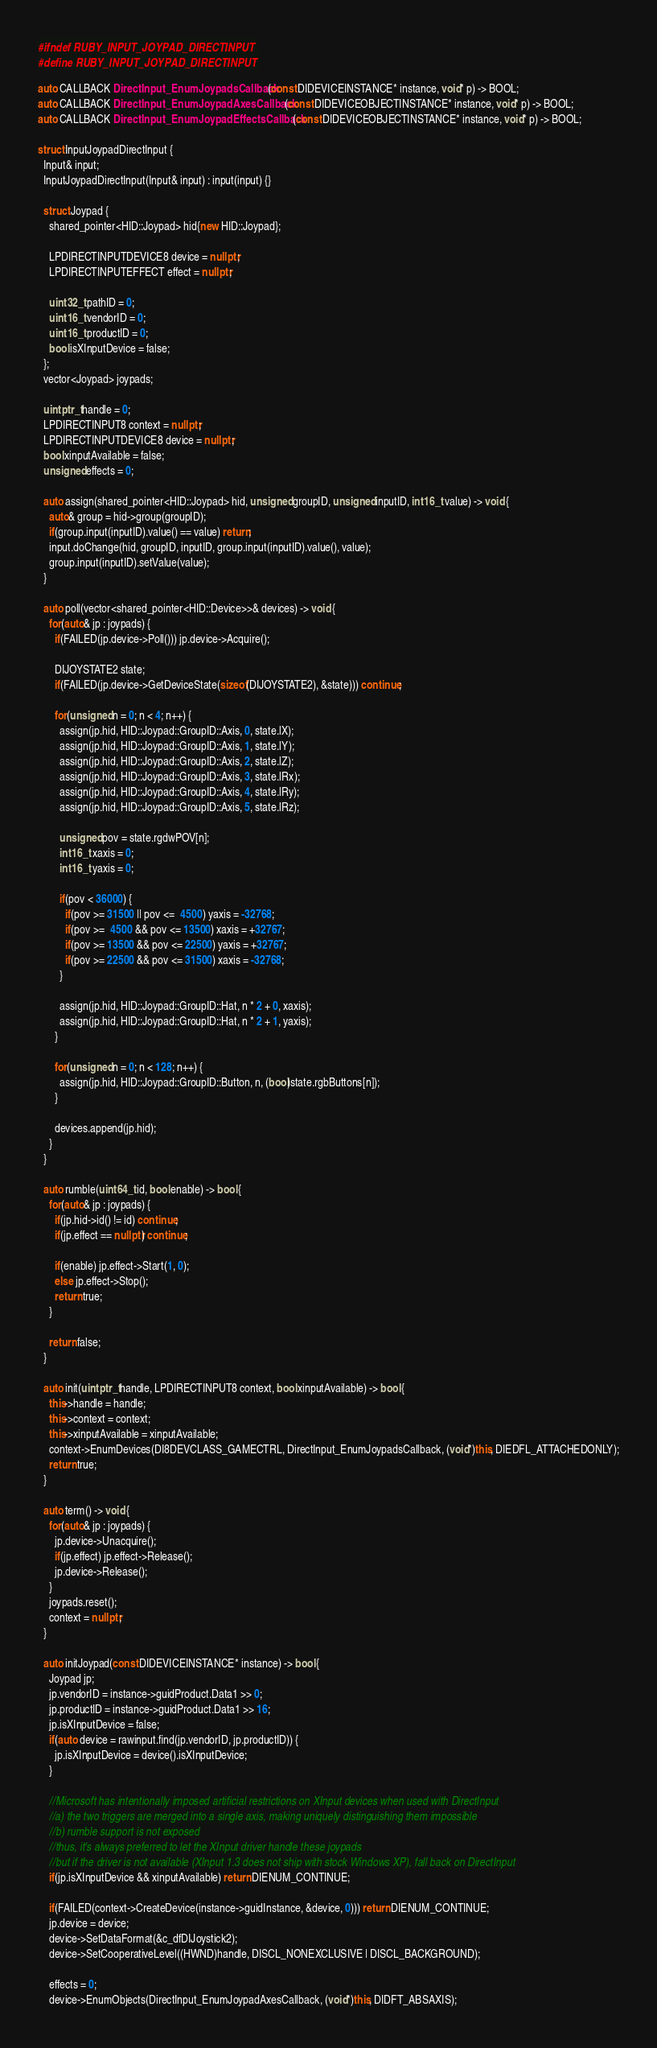<code> <loc_0><loc_0><loc_500><loc_500><_C++_>#ifndef RUBY_INPUT_JOYPAD_DIRECTINPUT
#define RUBY_INPUT_JOYPAD_DIRECTINPUT

auto CALLBACK DirectInput_EnumJoypadsCallback(const DIDEVICEINSTANCE* instance, void* p) -> BOOL;
auto CALLBACK DirectInput_EnumJoypadAxesCallback(const DIDEVICEOBJECTINSTANCE* instance, void* p) -> BOOL;
auto CALLBACK DirectInput_EnumJoypadEffectsCallback(const DIDEVICEOBJECTINSTANCE* instance, void* p) -> BOOL;

struct InputJoypadDirectInput {
  Input& input;
  InputJoypadDirectInput(Input& input) : input(input) {}

  struct Joypad {
    shared_pointer<HID::Joypad> hid{new HID::Joypad};

    LPDIRECTINPUTDEVICE8 device = nullptr;
    LPDIRECTINPUTEFFECT effect = nullptr;

    uint32_t pathID = 0;
    uint16_t vendorID = 0;
    uint16_t productID = 0;
    bool isXInputDevice = false;
  };
  vector<Joypad> joypads;

  uintptr_t handle = 0;
  LPDIRECTINPUT8 context = nullptr;
  LPDIRECTINPUTDEVICE8 device = nullptr;
  bool xinputAvailable = false;
  unsigned effects = 0;

  auto assign(shared_pointer<HID::Joypad> hid, unsigned groupID, unsigned inputID, int16_t value) -> void {
    auto& group = hid->group(groupID);
    if(group.input(inputID).value() == value) return;
    input.doChange(hid, groupID, inputID, group.input(inputID).value(), value);
    group.input(inputID).setValue(value);
  }

  auto poll(vector<shared_pointer<HID::Device>>& devices) -> void {
    for(auto& jp : joypads) {
      if(FAILED(jp.device->Poll())) jp.device->Acquire();

      DIJOYSTATE2 state;
      if(FAILED(jp.device->GetDeviceState(sizeof(DIJOYSTATE2), &state))) continue;

      for(unsigned n = 0; n < 4; n++) {
        assign(jp.hid, HID::Joypad::GroupID::Axis, 0, state.lX);
        assign(jp.hid, HID::Joypad::GroupID::Axis, 1, state.lY);
        assign(jp.hid, HID::Joypad::GroupID::Axis, 2, state.lZ);
        assign(jp.hid, HID::Joypad::GroupID::Axis, 3, state.lRx);
        assign(jp.hid, HID::Joypad::GroupID::Axis, 4, state.lRy);
        assign(jp.hid, HID::Joypad::GroupID::Axis, 5, state.lRz);

        unsigned pov = state.rgdwPOV[n];
        int16_t xaxis = 0;
        int16_t yaxis = 0;

        if(pov < 36000) {
          if(pov >= 31500 || pov <=  4500) yaxis = -32768;
          if(pov >=  4500 && pov <= 13500) xaxis = +32767;
          if(pov >= 13500 && pov <= 22500) yaxis = +32767;
          if(pov >= 22500 && pov <= 31500) xaxis = -32768;
        }

        assign(jp.hid, HID::Joypad::GroupID::Hat, n * 2 + 0, xaxis);
        assign(jp.hid, HID::Joypad::GroupID::Hat, n * 2 + 1, yaxis);
      }

      for(unsigned n = 0; n < 128; n++) {
        assign(jp.hid, HID::Joypad::GroupID::Button, n, (bool)state.rgbButtons[n]);
      }

      devices.append(jp.hid);
    }
  }

  auto rumble(uint64_t id, bool enable) -> bool {
    for(auto& jp : joypads) {
      if(jp.hid->id() != id) continue;
      if(jp.effect == nullptr) continue;

      if(enable) jp.effect->Start(1, 0);
      else jp.effect->Stop();
      return true;
    }

    return false;
  }

  auto init(uintptr_t handle, LPDIRECTINPUT8 context, bool xinputAvailable) -> bool {
    this->handle = handle;
    this->context = context;
    this->xinputAvailable = xinputAvailable;
    context->EnumDevices(DI8DEVCLASS_GAMECTRL, DirectInput_EnumJoypadsCallback, (void*)this, DIEDFL_ATTACHEDONLY);
    return true;
  }

  auto term() -> void {
    for(auto& jp : joypads) {
      jp.device->Unacquire();
      if(jp.effect) jp.effect->Release();
      jp.device->Release();
    }
    joypads.reset();
    context = nullptr;
  }

  auto initJoypad(const DIDEVICEINSTANCE* instance) -> bool {
    Joypad jp;
    jp.vendorID = instance->guidProduct.Data1 >> 0;
    jp.productID = instance->guidProduct.Data1 >> 16;
    jp.isXInputDevice = false;
    if(auto device = rawinput.find(jp.vendorID, jp.productID)) {
      jp.isXInputDevice = device().isXInputDevice;
    }

    //Microsoft has intentionally imposed artificial restrictions on XInput devices when used with DirectInput
    //a) the two triggers are merged into a single axis, making uniquely distinguishing them impossible
    //b) rumble support is not exposed
    //thus, it's always preferred to let the XInput driver handle these joypads
    //but if the driver is not available (XInput 1.3 does not ship with stock Windows XP), fall back on DirectInput
    if(jp.isXInputDevice && xinputAvailable) return DIENUM_CONTINUE;

    if(FAILED(context->CreateDevice(instance->guidInstance, &device, 0))) return DIENUM_CONTINUE;
    jp.device = device;
    device->SetDataFormat(&c_dfDIJoystick2);
    device->SetCooperativeLevel((HWND)handle, DISCL_NONEXCLUSIVE | DISCL_BACKGROUND);

    effects = 0;
    device->EnumObjects(DirectInput_EnumJoypadAxesCallback, (void*)this, DIDFT_ABSAXIS);</code> 